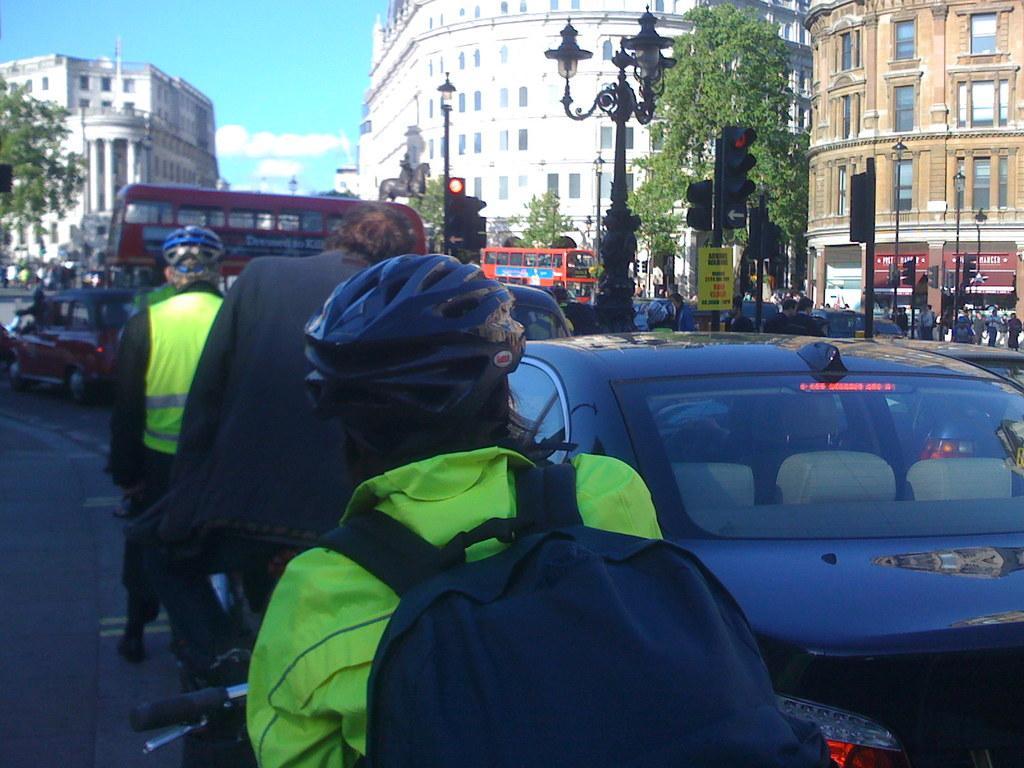Please provide a concise description of this image. In this image are vehicles and people are on a road, in the background there are buildings trees, light poles and statue and the sky. 